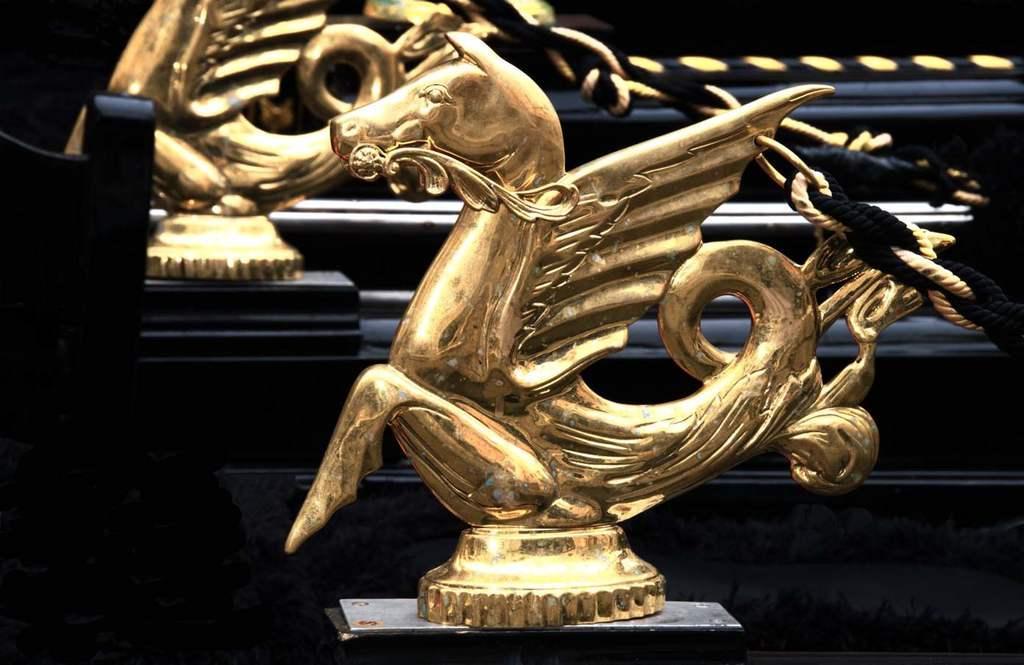In one or two sentences, can you explain what this image depicts? In this image there is an object in the left corner. There are ropes in the right corner. There are statues in the foreground. 